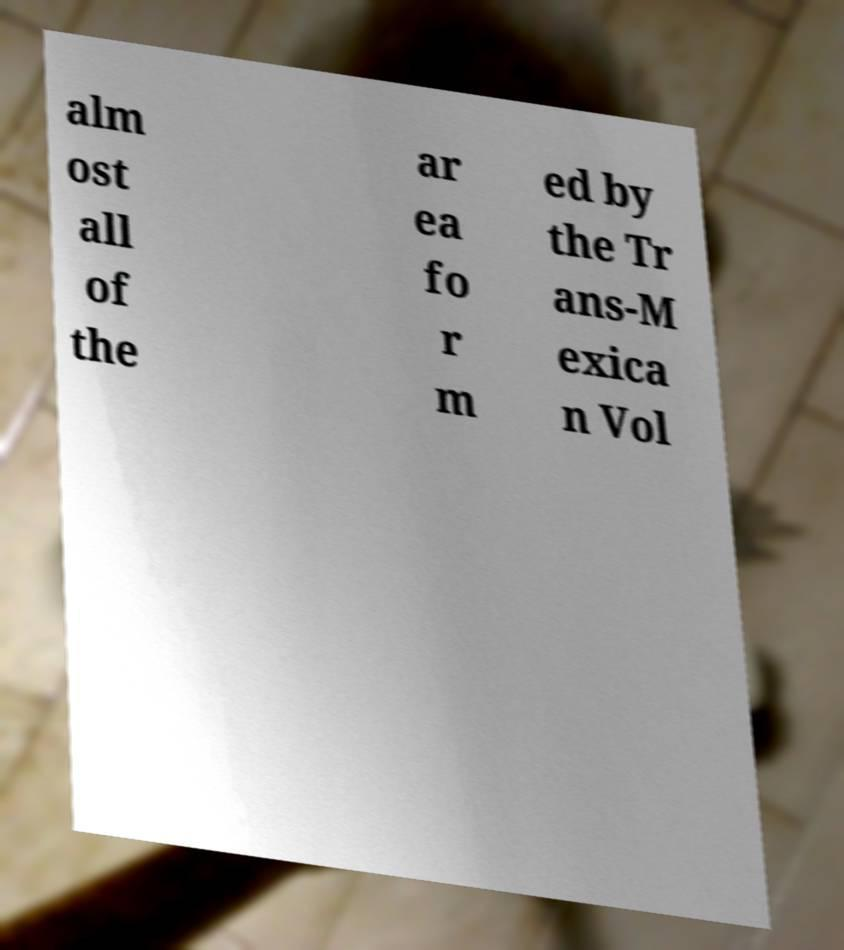What messages or text are displayed in this image? I need them in a readable, typed format. alm ost all of the ar ea fo r m ed by the Tr ans-M exica n Vol 